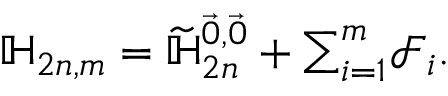<formula> <loc_0><loc_0><loc_500><loc_500>\mathbb { H } _ { 2 n , m } = \widetilde { \mathbb { H } } _ { 2 n } ^ { \vec { 0 } , \vec { 0 } } + \sum _ { i = 1 } ^ { m } \mathcal { F } _ { i } .</formula> 